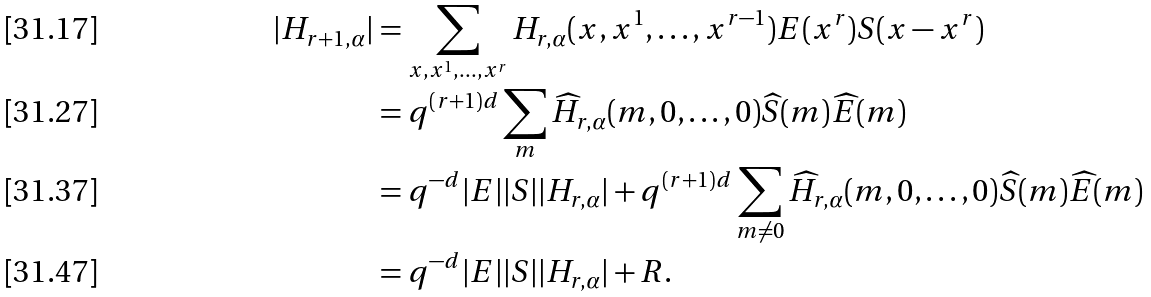<formula> <loc_0><loc_0><loc_500><loc_500>| H _ { r + 1 , \alpha } | & = \sum _ { x , x ^ { 1 } , \dots , x ^ { r } } H _ { r , \alpha } ( x , x ^ { 1 } , \dots , x ^ { r - 1 } ) E ( x ^ { r } ) S ( x - x ^ { r } ) \\ & = q ^ { ( r + 1 ) d } \sum _ { m } \widehat { H } _ { r , \alpha } ( m , 0 , \dots , 0 ) \widehat { S } ( m ) \widehat { E } ( m ) \\ & = q ^ { - d } | E | | S | | H _ { r , \alpha } | + q ^ { ( r + 1 ) d } \sum _ { m \neq 0 } \widehat { H } _ { r , \alpha } ( m , 0 , \dots , 0 ) \widehat { S } ( m ) \widehat { E } ( m ) \\ & = q ^ { - d } | E | | S | | H _ { r , \alpha } | + R .</formula> 